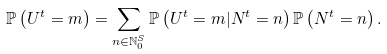<formula> <loc_0><loc_0><loc_500><loc_500>\mathbb { P } \left ( U ^ { t } = m \right ) = \sum _ { n \in \mathbb { N } _ { 0 } ^ { S } } \mathbb { P } \left ( U ^ { t } = m | N ^ { t } = n \right ) \mathbb { P } \left ( N ^ { t } = n \right ) .</formula> 